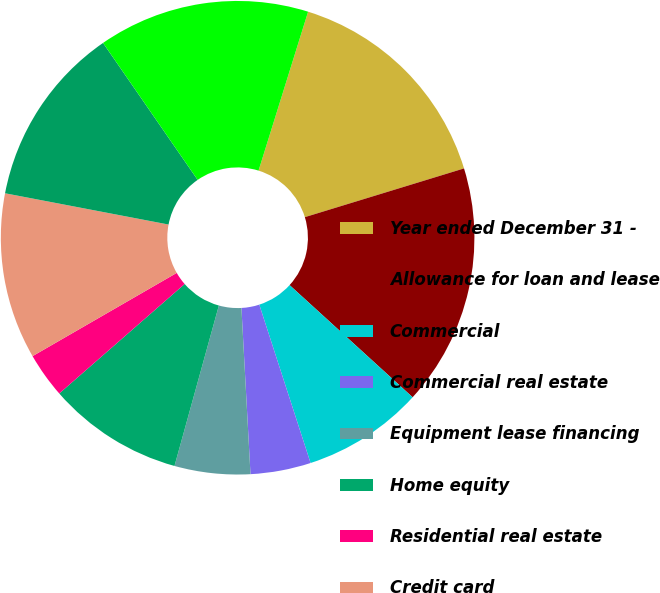Convert chart. <chart><loc_0><loc_0><loc_500><loc_500><pie_chart><fcel>Year ended December 31 -<fcel>Allowance for loan and lease<fcel>Commercial<fcel>Commercial real estate<fcel>Equipment lease financing<fcel>Home equity<fcel>Residential real estate<fcel>Credit card<fcel>Other consumer (a) Total gross<fcel>Net (charge-offs)<nl><fcel>15.46%<fcel>16.49%<fcel>8.25%<fcel>4.12%<fcel>5.16%<fcel>9.28%<fcel>3.09%<fcel>11.34%<fcel>12.37%<fcel>14.43%<nl></chart> 